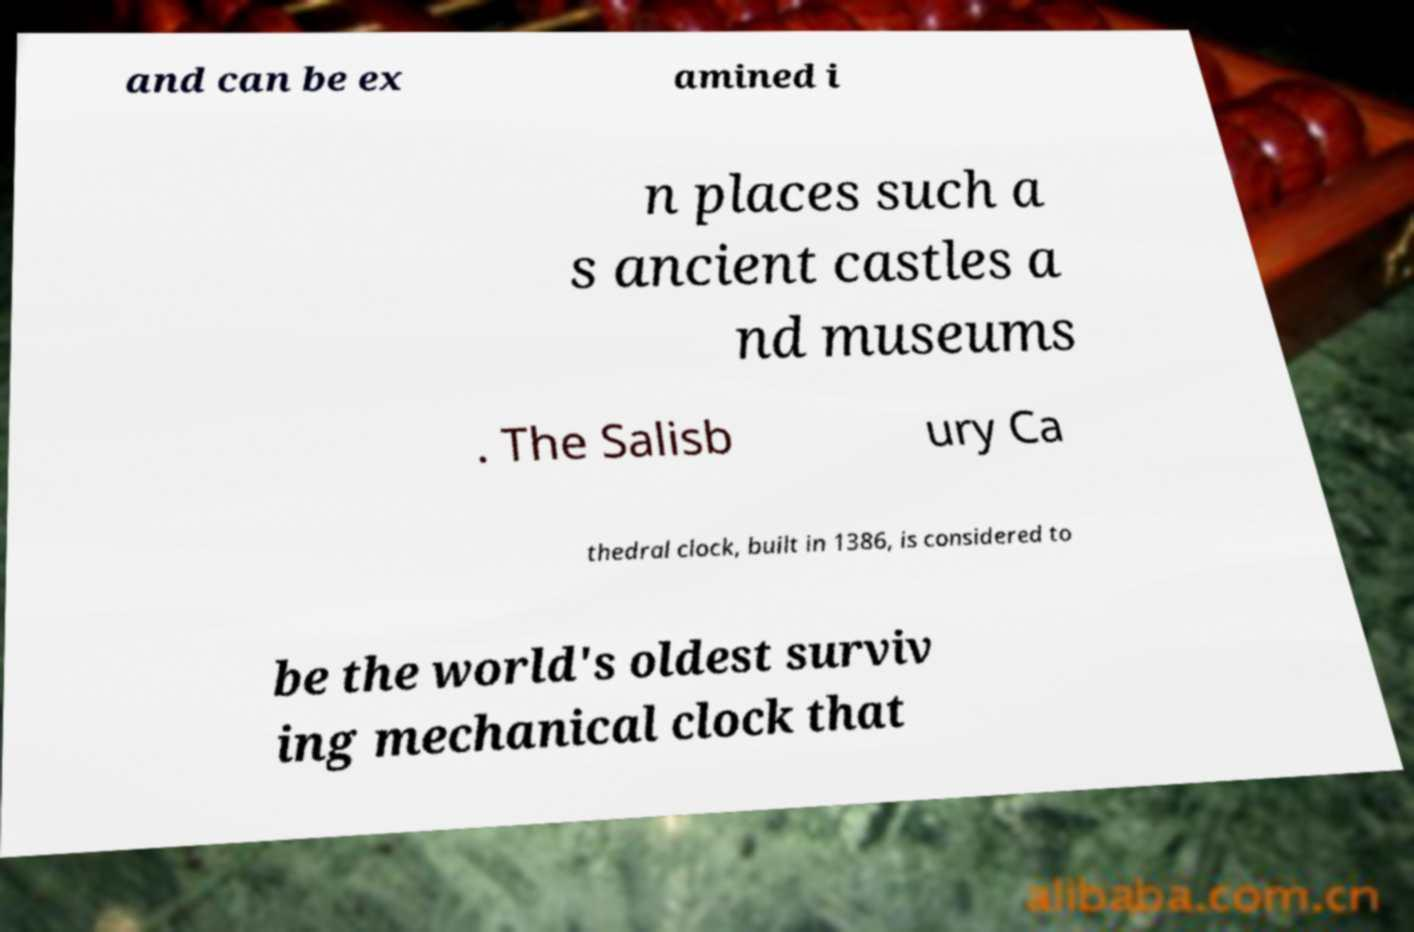Please identify and transcribe the text found in this image. and can be ex amined i n places such a s ancient castles a nd museums . The Salisb ury Ca thedral clock, built in 1386, is considered to be the world's oldest surviv ing mechanical clock that 